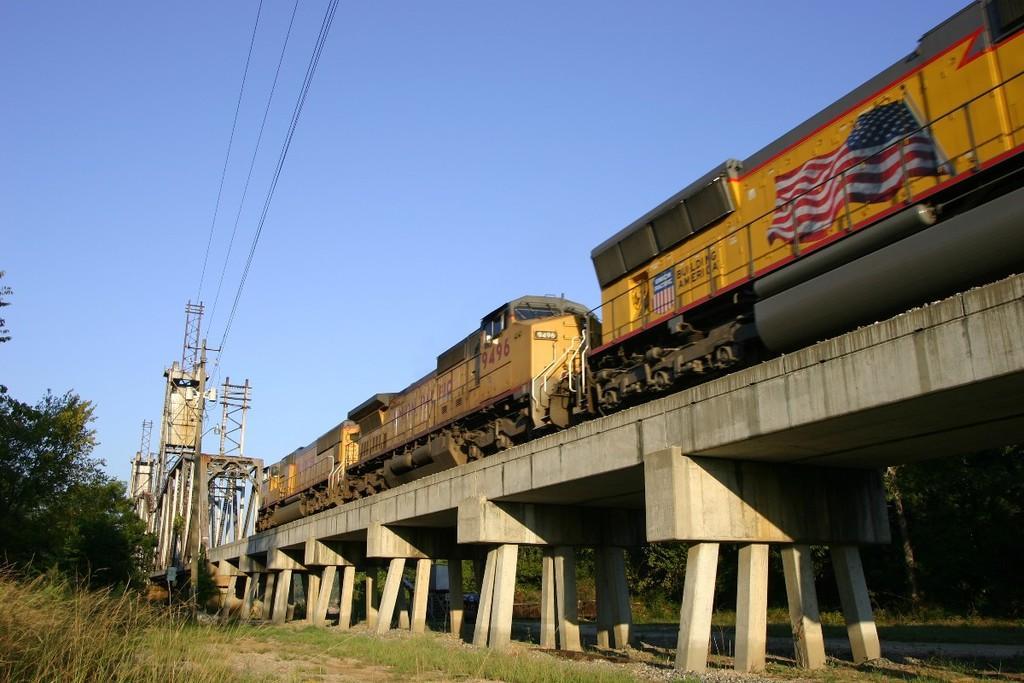Describe this image in one or two sentences. In this image there is a train on the track, which is on the bridge and there is a metal structure connected with cables. On the left and right side of the bridge there are trees and grass. In the background there is the sky. 